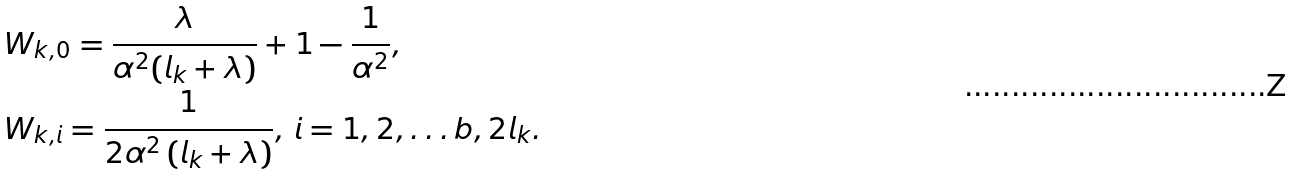<formula> <loc_0><loc_0><loc_500><loc_500>& W _ { k , 0 } = \frac { \lambda } { \alpha ^ { 2 } ( l _ { k } + \lambda ) } + 1 - \frac { 1 } { \alpha ^ { 2 } } , \\ & W _ { k , i } = \frac { 1 } { 2 \alpha ^ { 2 } \left ( l _ { k } + \lambda \right ) } , \, i = 1 , 2 , \dots b , 2 l _ { k } . \\</formula> 